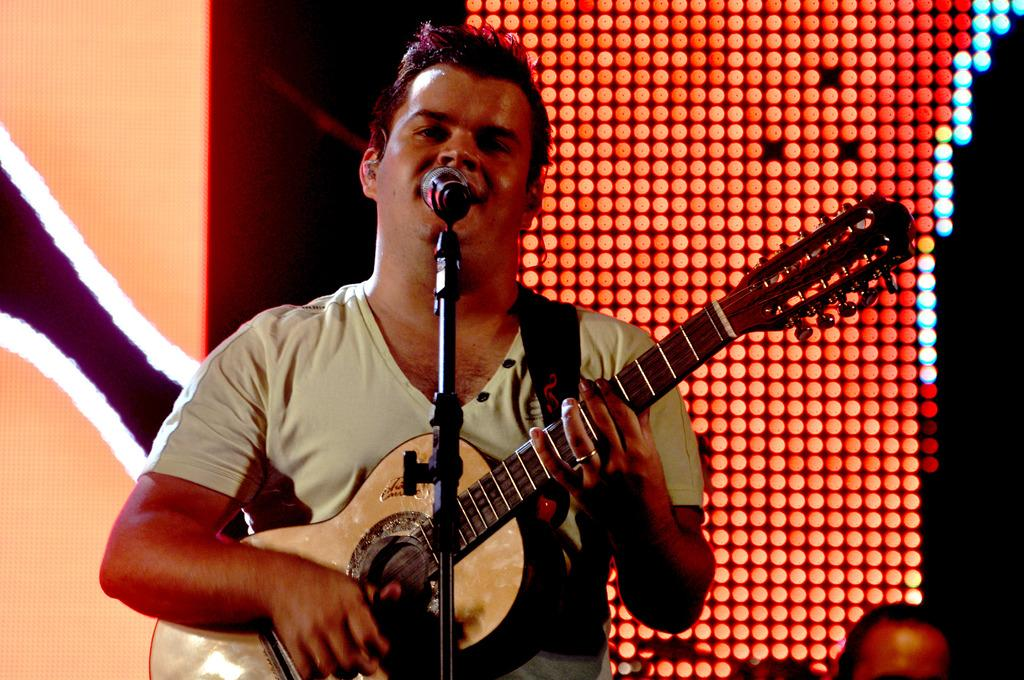What is the man in the image doing? The man is playing the guitar and singing. What object is the man holding in the image? The man is holding a guitar. Where is the man positioned in relation to the microphone? The man is in front of a microphone. What can be seen in the background of the image? There are lights visible in the background of the image. What type of jeans is the man wearing in the image? There is no information about the man's jeans in the image, so we cannot determine the type. Can you tell me how many toothbrushes are visible in the image? There are no toothbrushes present in the image. 